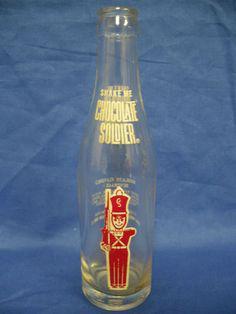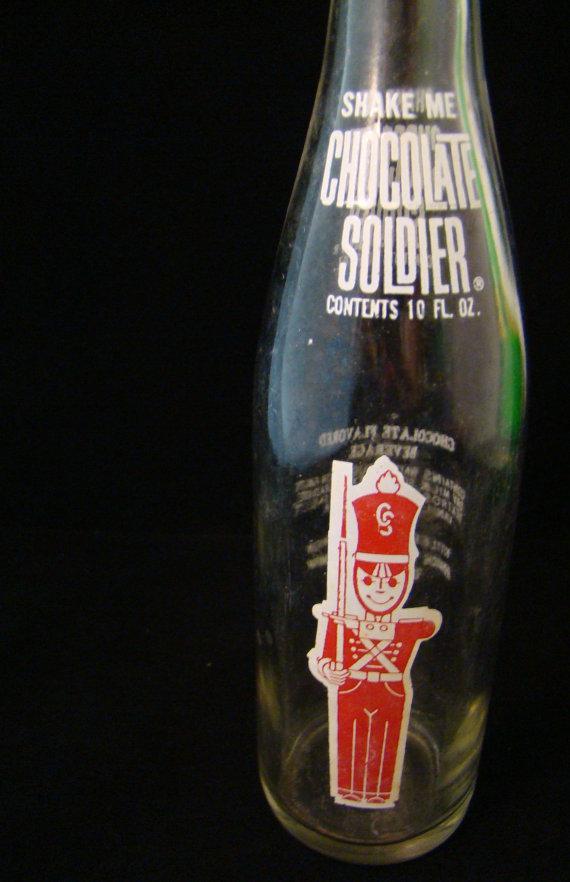The first image is the image on the left, the second image is the image on the right. For the images displayed, is the sentence "The right image contains exactly three bottles." factually correct? Answer yes or no. No. The first image is the image on the left, the second image is the image on the right. For the images displayed, is the sentence "Each image shows a single glass bottle, at least one of the pictured bottles is empty, and at least one bottle has a red 'toy soldier' depicted on the front." factually correct? Answer yes or no. Yes. 